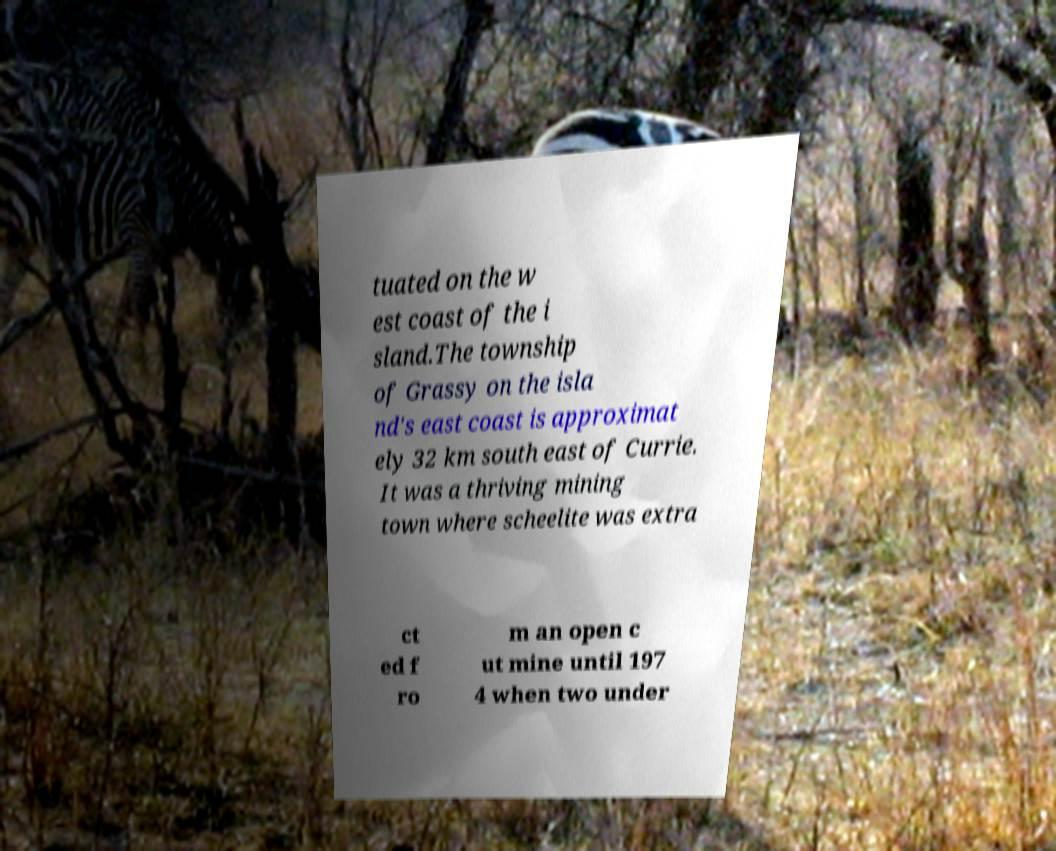I need the written content from this picture converted into text. Can you do that? tuated on the w est coast of the i sland.The township of Grassy on the isla nd's east coast is approximat ely 32 km south east of Currie. It was a thriving mining town where scheelite was extra ct ed f ro m an open c ut mine until 197 4 when two under 